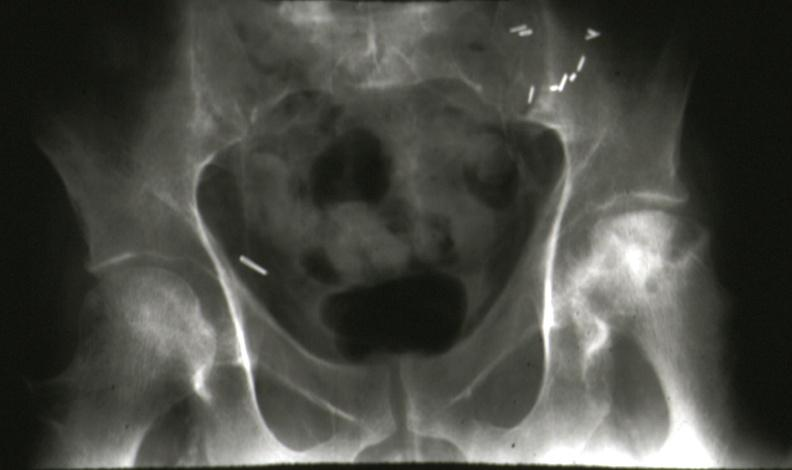what is present?
Answer the question using a single word or phrase. Joints 